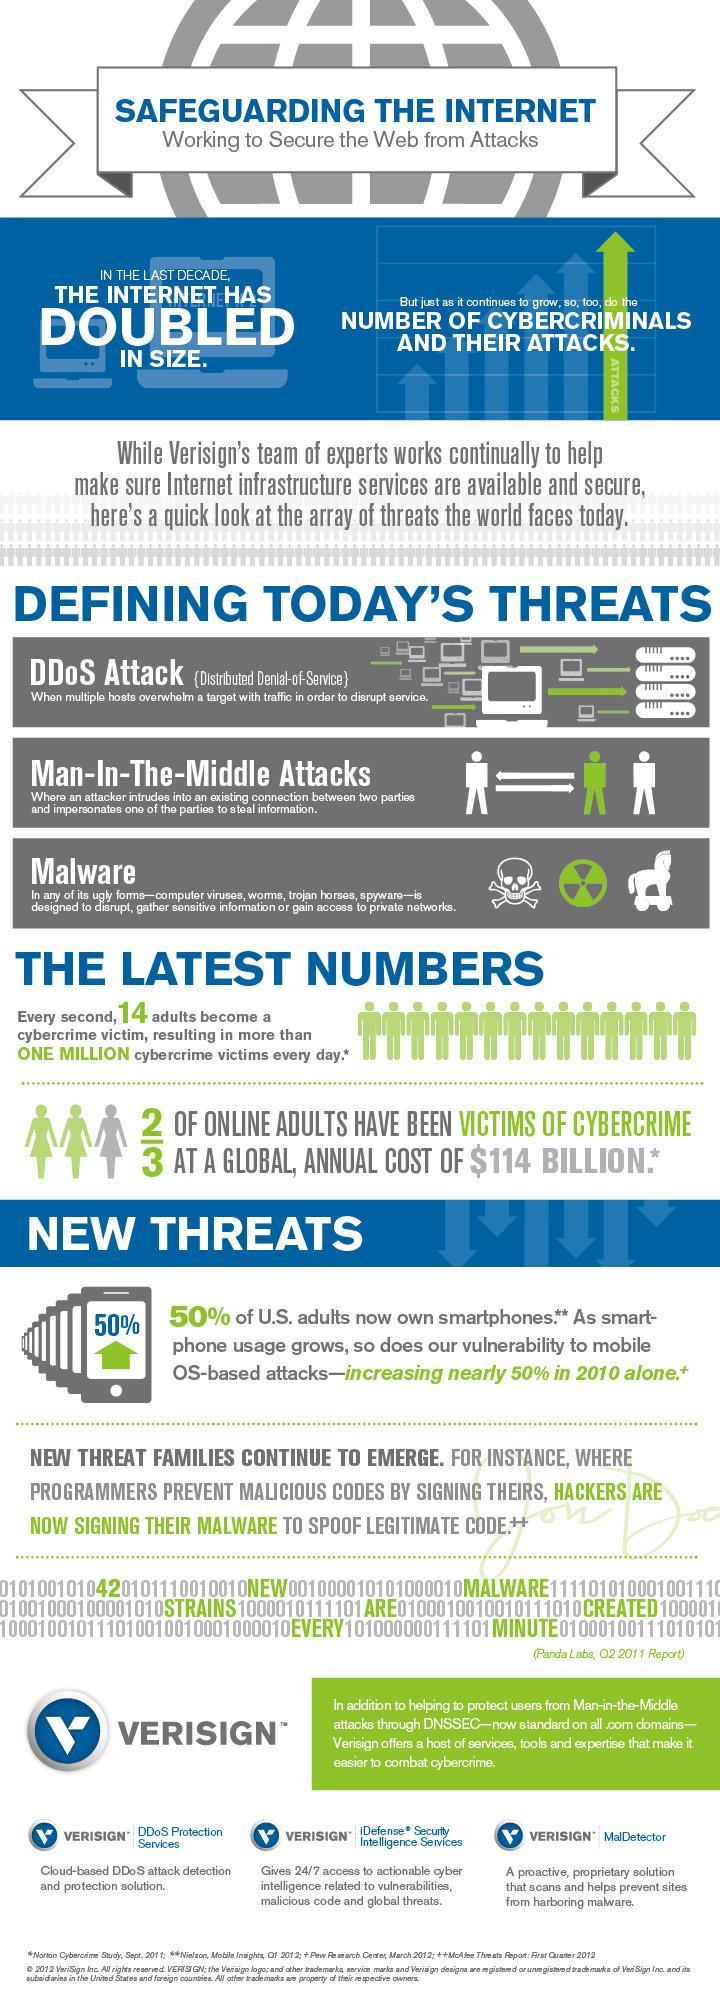Out of 3, how many online adults have not been a victim of cybercrime?
Answer the question with a short phrase. 1 